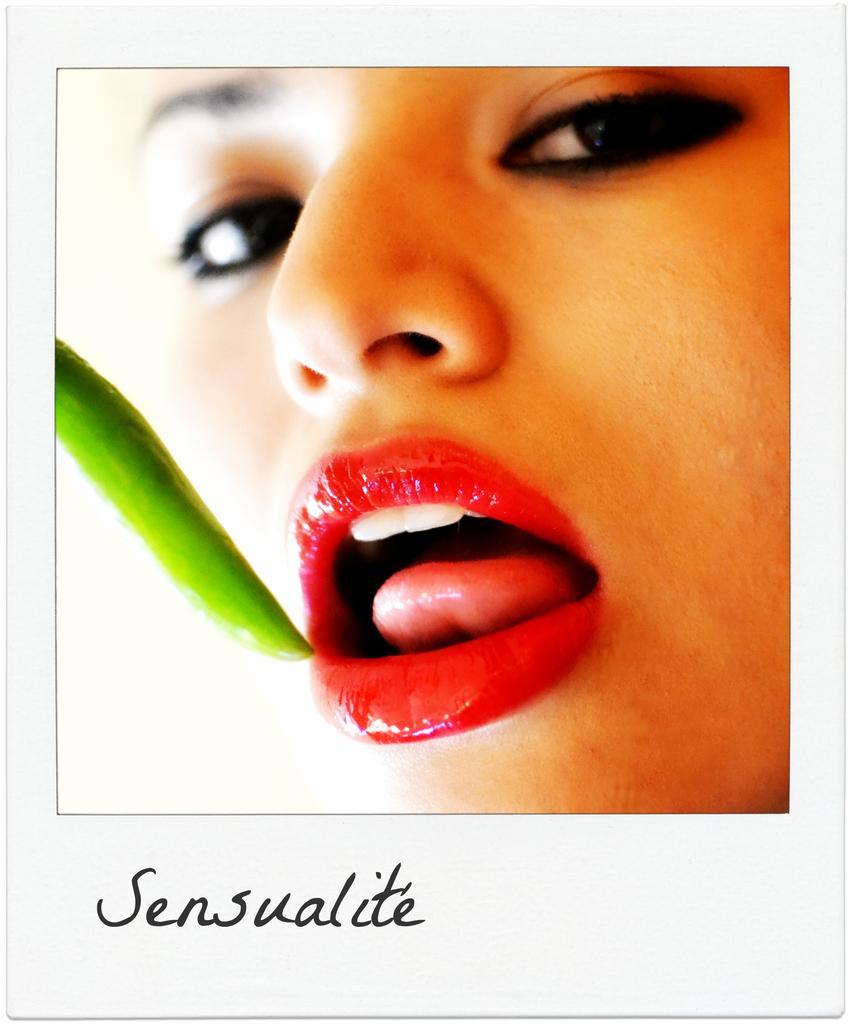How would you summarize this image in a sentence or two? This image consists of a photograph. In this image there is a woman and there is a chilly. 